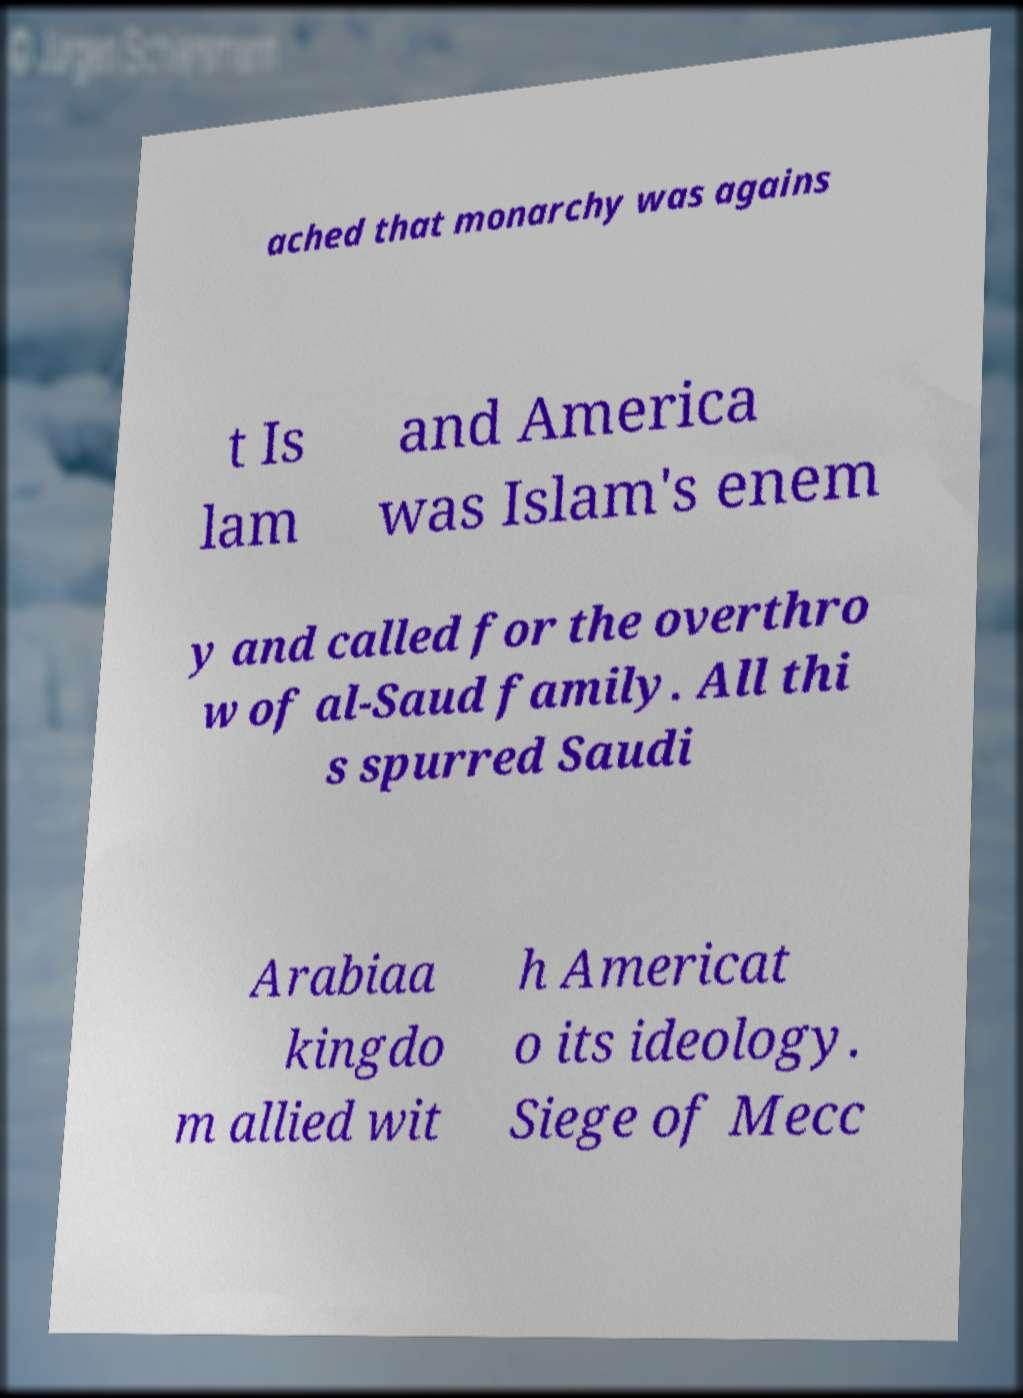Can you read and provide the text displayed in the image?This photo seems to have some interesting text. Can you extract and type it out for me? ached that monarchy was agains t Is lam and America was Islam's enem y and called for the overthro w of al-Saud family. All thi s spurred Saudi Arabiaa kingdo m allied wit h Americat o its ideology. Siege of Mecc 